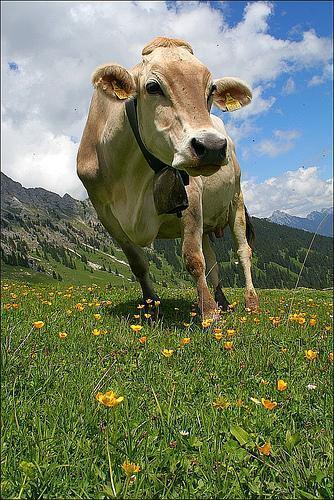How many cows?
Give a very brief answer. 1. How many people have their feet park on skateboard?
Give a very brief answer. 0. 